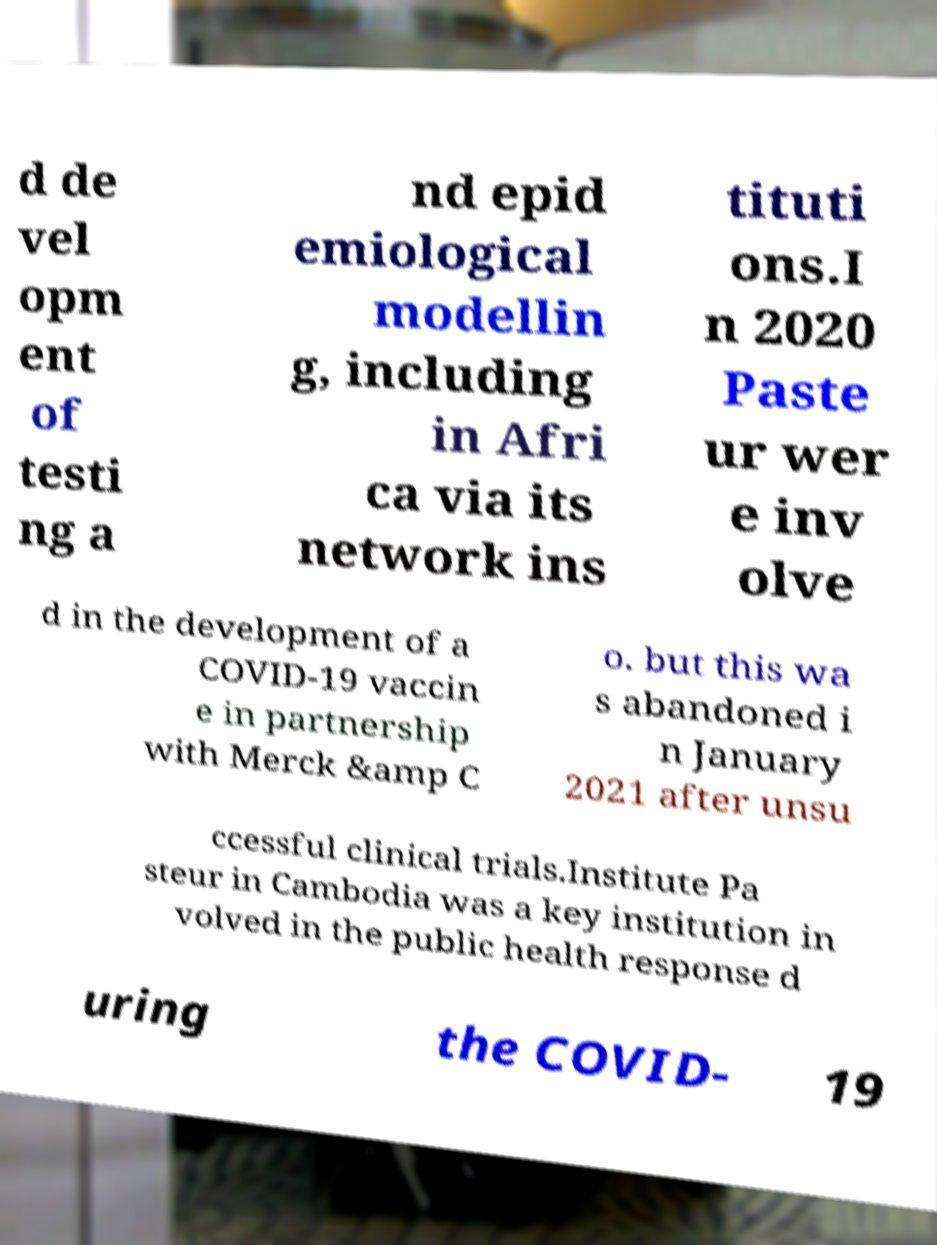Please read and relay the text visible in this image. What does it say? d de vel opm ent of testi ng a nd epid emiological modellin g, including in Afri ca via its network ins tituti ons.I n 2020 Paste ur wer e inv olve d in the development of a COVID-19 vaccin e in partnership with Merck &amp C o. but this wa s abandoned i n January 2021 after unsu ccessful clinical trials.Institute Pa steur in Cambodia was a key institution in volved in the public health response d uring the COVID- 19 